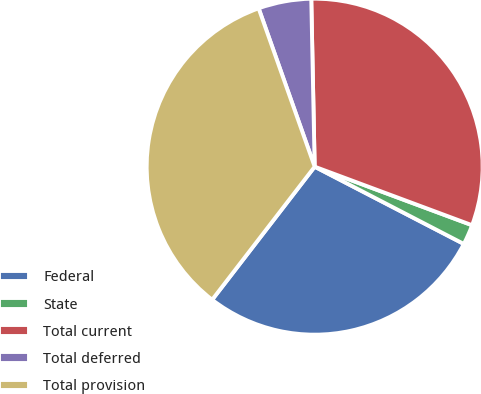Convert chart to OTSL. <chart><loc_0><loc_0><loc_500><loc_500><pie_chart><fcel>Federal<fcel>State<fcel>Total current<fcel>Total deferred<fcel>Total provision<nl><fcel>27.84%<fcel>1.94%<fcel>30.99%<fcel>5.09%<fcel>34.14%<nl></chart> 